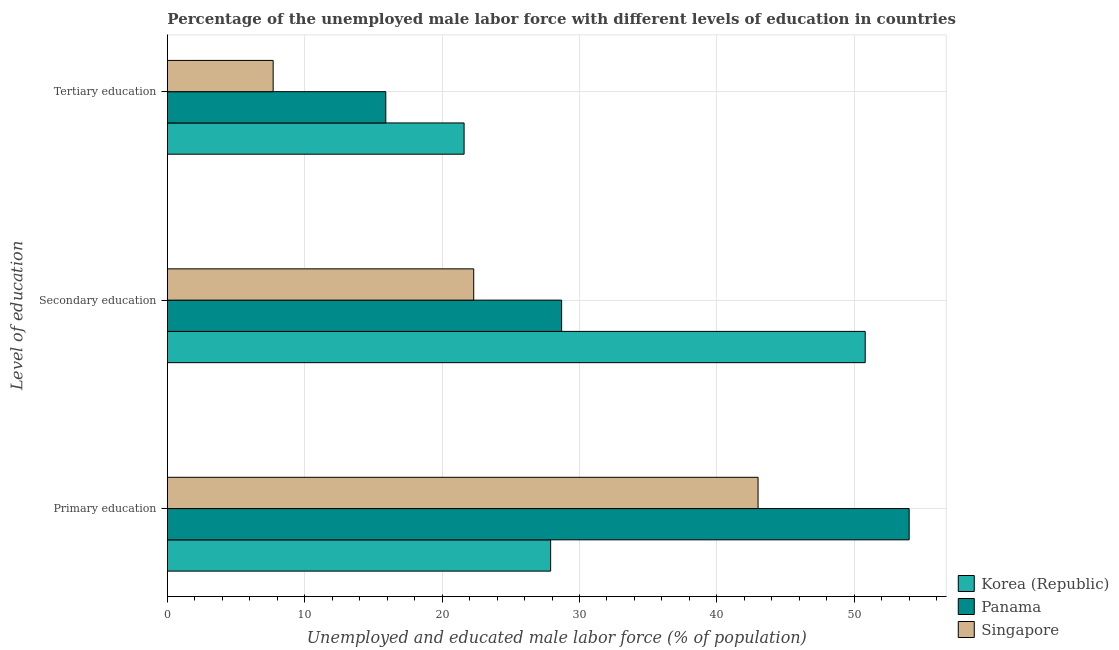How many different coloured bars are there?
Make the answer very short. 3. How many groups of bars are there?
Provide a short and direct response. 3. How many bars are there on the 3rd tick from the top?
Offer a very short reply. 3. How many bars are there on the 2nd tick from the bottom?
Offer a very short reply. 3. What is the label of the 2nd group of bars from the top?
Make the answer very short. Secondary education. What is the percentage of male labor force who received secondary education in Korea (Republic)?
Offer a very short reply. 50.8. Across all countries, what is the minimum percentage of male labor force who received primary education?
Provide a succinct answer. 27.9. In which country was the percentage of male labor force who received secondary education minimum?
Offer a very short reply. Singapore. What is the total percentage of male labor force who received secondary education in the graph?
Make the answer very short. 101.8. What is the difference between the percentage of male labor force who received primary education in Panama and that in Korea (Republic)?
Provide a succinct answer. 26.1. What is the difference between the percentage of male labor force who received secondary education in Panama and the percentage of male labor force who received tertiary education in Singapore?
Provide a succinct answer. 21. What is the average percentage of male labor force who received primary education per country?
Keep it short and to the point. 41.63. What is the difference between the percentage of male labor force who received primary education and percentage of male labor force who received tertiary education in Korea (Republic)?
Provide a short and direct response. 6.3. What is the ratio of the percentage of male labor force who received secondary education in Panama to that in Singapore?
Make the answer very short. 1.29. Is the percentage of male labor force who received tertiary education in Panama less than that in Singapore?
Offer a terse response. No. What is the difference between the highest and the second highest percentage of male labor force who received tertiary education?
Offer a terse response. 5.7. What is the difference between the highest and the lowest percentage of male labor force who received secondary education?
Your answer should be compact. 28.5. In how many countries, is the percentage of male labor force who received primary education greater than the average percentage of male labor force who received primary education taken over all countries?
Your answer should be very brief. 2. Is the sum of the percentage of male labor force who received primary education in Panama and Korea (Republic) greater than the maximum percentage of male labor force who received secondary education across all countries?
Your answer should be very brief. Yes. What does the 2nd bar from the bottom in Tertiary education represents?
Offer a very short reply. Panama. Is it the case that in every country, the sum of the percentage of male labor force who received primary education and percentage of male labor force who received secondary education is greater than the percentage of male labor force who received tertiary education?
Ensure brevity in your answer.  Yes. Are all the bars in the graph horizontal?
Your response must be concise. Yes. How many countries are there in the graph?
Ensure brevity in your answer.  3. What is the difference between two consecutive major ticks on the X-axis?
Offer a terse response. 10. Are the values on the major ticks of X-axis written in scientific E-notation?
Your response must be concise. No. Does the graph contain any zero values?
Keep it short and to the point. No. Does the graph contain grids?
Offer a terse response. Yes. What is the title of the graph?
Make the answer very short. Percentage of the unemployed male labor force with different levels of education in countries. What is the label or title of the X-axis?
Make the answer very short. Unemployed and educated male labor force (% of population). What is the label or title of the Y-axis?
Give a very brief answer. Level of education. What is the Unemployed and educated male labor force (% of population) of Korea (Republic) in Primary education?
Keep it short and to the point. 27.9. What is the Unemployed and educated male labor force (% of population) in Singapore in Primary education?
Provide a short and direct response. 43. What is the Unemployed and educated male labor force (% of population) in Korea (Republic) in Secondary education?
Your answer should be compact. 50.8. What is the Unemployed and educated male labor force (% of population) in Panama in Secondary education?
Offer a terse response. 28.7. What is the Unemployed and educated male labor force (% of population) in Singapore in Secondary education?
Offer a very short reply. 22.3. What is the Unemployed and educated male labor force (% of population) of Korea (Republic) in Tertiary education?
Your response must be concise. 21.6. What is the Unemployed and educated male labor force (% of population) in Panama in Tertiary education?
Offer a terse response. 15.9. What is the Unemployed and educated male labor force (% of population) in Singapore in Tertiary education?
Ensure brevity in your answer.  7.7. Across all Level of education, what is the maximum Unemployed and educated male labor force (% of population) of Korea (Republic)?
Offer a very short reply. 50.8. Across all Level of education, what is the maximum Unemployed and educated male labor force (% of population) of Panama?
Your response must be concise. 54. Across all Level of education, what is the minimum Unemployed and educated male labor force (% of population) of Korea (Republic)?
Your response must be concise. 21.6. Across all Level of education, what is the minimum Unemployed and educated male labor force (% of population) of Panama?
Your answer should be compact. 15.9. Across all Level of education, what is the minimum Unemployed and educated male labor force (% of population) in Singapore?
Keep it short and to the point. 7.7. What is the total Unemployed and educated male labor force (% of population) of Korea (Republic) in the graph?
Your answer should be compact. 100.3. What is the total Unemployed and educated male labor force (% of population) of Panama in the graph?
Your answer should be very brief. 98.6. What is the total Unemployed and educated male labor force (% of population) of Singapore in the graph?
Provide a short and direct response. 73. What is the difference between the Unemployed and educated male labor force (% of population) in Korea (Republic) in Primary education and that in Secondary education?
Your answer should be compact. -22.9. What is the difference between the Unemployed and educated male labor force (% of population) of Panama in Primary education and that in Secondary education?
Make the answer very short. 25.3. What is the difference between the Unemployed and educated male labor force (% of population) of Singapore in Primary education and that in Secondary education?
Offer a very short reply. 20.7. What is the difference between the Unemployed and educated male labor force (% of population) in Korea (Republic) in Primary education and that in Tertiary education?
Provide a succinct answer. 6.3. What is the difference between the Unemployed and educated male labor force (% of population) in Panama in Primary education and that in Tertiary education?
Your answer should be compact. 38.1. What is the difference between the Unemployed and educated male labor force (% of population) in Singapore in Primary education and that in Tertiary education?
Give a very brief answer. 35.3. What is the difference between the Unemployed and educated male labor force (% of population) of Korea (Republic) in Secondary education and that in Tertiary education?
Ensure brevity in your answer.  29.2. What is the difference between the Unemployed and educated male labor force (% of population) in Singapore in Secondary education and that in Tertiary education?
Offer a terse response. 14.6. What is the difference between the Unemployed and educated male labor force (% of population) in Korea (Republic) in Primary education and the Unemployed and educated male labor force (% of population) in Panama in Secondary education?
Your answer should be compact. -0.8. What is the difference between the Unemployed and educated male labor force (% of population) in Panama in Primary education and the Unemployed and educated male labor force (% of population) in Singapore in Secondary education?
Offer a terse response. 31.7. What is the difference between the Unemployed and educated male labor force (% of population) in Korea (Republic) in Primary education and the Unemployed and educated male labor force (% of population) in Panama in Tertiary education?
Your response must be concise. 12. What is the difference between the Unemployed and educated male labor force (% of population) in Korea (Republic) in Primary education and the Unemployed and educated male labor force (% of population) in Singapore in Tertiary education?
Your answer should be very brief. 20.2. What is the difference between the Unemployed and educated male labor force (% of population) of Panama in Primary education and the Unemployed and educated male labor force (% of population) of Singapore in Tertiary education?
Offer a terse response. 46.3. What is the difference between the Unemployed and educated male labor force (% of population) in Korea (Republic) in Secondary education and the Unemployed and educated male labor force (% of population) in Panama in Tertiary education?
Provide a succinct answer. 34.9. What is the difference between the Unemployed and educated male labor force (% of population) of Korea (Republic) in Secondary education and the Unemployed and educated male labor force (% of population) of Singapore in Tertiary education?
Ensure brevity in your answer.  43.1. What is the difference between the Unemployed and educated male labor force (% of population) in Panama in Secondary education and the Unemployed and educated male labor force (% of population) in Singapore in Tertiary education?
Make the answer very short. 21. What is the average Unemployed and educated male labor force (% of population) of Korea (Republic) per Level of education?
Offer a very short reply. 33.43. What is the average Unemployed and educated male labor force (% of population) in Panama per Level of education?
Ensure brevity in your answer.  32.87. What is the average Unemployed and educated male labor force (% of population) in Singapore per Level of education?
Make the answer very short. 24.33. What is the difference between the Unemployed and educated male labor force (% of population) of Korea (Republic) and Unemployed and educated male labor force (% of population) of Panama in Primary education?
Ensure brevity in your answer.  -26.1. What is the difference between the Unemployed and educated male labor force (% of population) of Korea (Republic) and Unemployed and educated male labor force (% of population) of Singapore in Primary education?
Give a very brief answer. -15.1. What is the difference between the Unemployed and educated male labor force (% of population) in Korea (Republic) and Unemployed and educated male labor force (% of population) in Panama in Secondary education?
Ensure brevity in your answer.  22.1. What is the difference between the Unemployed and educated male labor force (% of population) of Korea (Republic) and Unemployed and educated male labor force (% of population) of Singapore in Secondary education?
Your answer should be compact. 28.5. What is the difference between the Unemployed and educated male labor force (% of population) in Korea (Republic) and Unemployed and educated male labor force (% of population) in Panama in Tertiary education?
Keep it short and to the point. 5.7. What is the difference between the Unemployed and educated male labor force (% of population) of Korea (Republic) and Unemployed and educated male labor force (% of population) of Singapore in Tertiary education?
Give a very brief answer. 13.9. What is the difference between the Unemployed and educated male labor force (% of population) of Panama and Unemployed and educated male labor force (% of population) of Singapore in Tertiary education?
Give a very brief answer. 8.2. What is the ratio of the Unemployed and educated male labor force (% of population) of Korea (Republic) in Primary education to that in Secondary education?
Keep it short and to the point. 0.55. What is the ratio of the Unemployed and educated male labor force (% of population) in Panama in Primary education to that in Secondary education?
Your answer should be compact. 1.88. What is the ratio of the Unemployed and educated male labor force (% of population) of Singapore in Primary education to that in Secondary education?
Make the answer very short. 1.93. What is the ratio of the Unemployed and educated male labor force (% of population) in Korea (Republic) in Primary education to that in Tertiary education?
Offer a terse response. 1.29. What is the ratio of the Unemployed and educated male labor force (% of population) in Panama in Primary education to that in Tertiary education?
Offer a terse response. 3.4. What is the ratio of the Unemployed and educated male labor force (% of population) in Singapore in Primary education to that in Tertiary education?
Offer a very short reply. 5.58. What is the ratio of the Unemployed and educated male labor force (% of population) of Korea (Republic) in Secondary education to that in Tertiary education?
Give a very brief answer. 2.35. What is the ratio of the Unemployed and educated male labor force (% of population) of Panama in Secondary education to that in Tertiary education?
Keep it short and to the point. 1.8. What is the ratio of the Unemployed and educated male labor force (% of population) in Singapore in Secondary education to that in Tertiary education?
Give a very brief answer. 2.9. What is the difference between the highest and the second highest Unemployed and educated male labor force (% of population) of Korea (Republic)?
Provide a short and direct response. 22.9. What is the difference between the highest and the second highest Unemployed and educated male labor force (% of population) of Panama?
Give a very brief answer. 25.3. What is the difference between the highest and the second highest Unemployed and educated male labor force (% of population) of Singapore?
Give a very brief answer. 20.7. What is the difference between the highest and the lowest Unemployed and educated male labor force (% of population) in Korea (Republic)?
Your answer should be compact. 29.2. What is the difference between the highest and the lowest Unemployed and educated male labor force (% of population) of Panama?
Ensure brevity in your answer.  38.1. What is the difference between the highest and the lowest Unemployed and educated male labor force (% of population) in Singapore?
Your response must be concise. 35.3. 